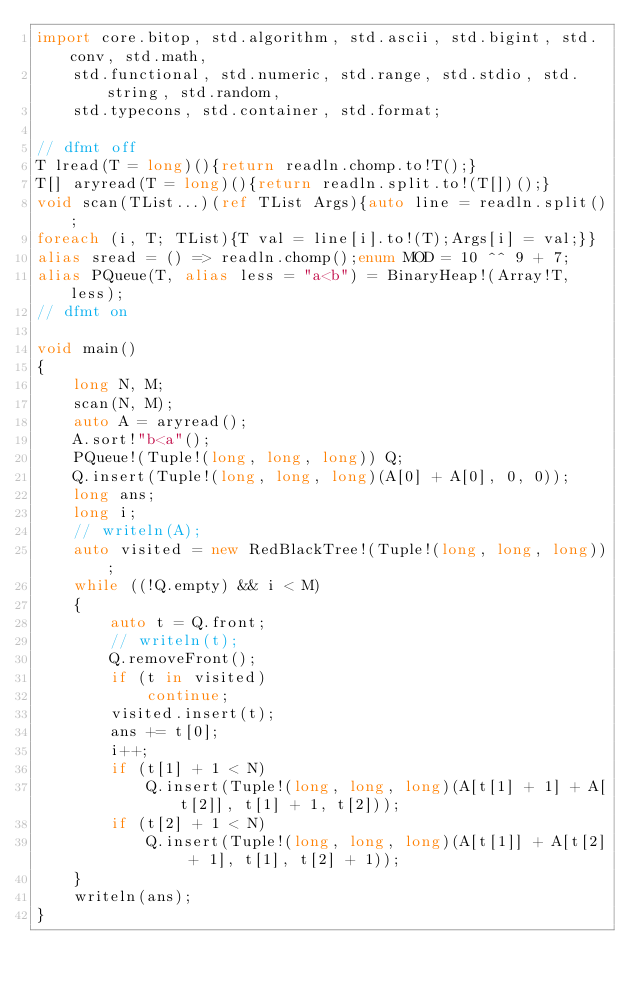Convert code to text. <code><loc_0><loc_0><loc_500><loc_500><_D_>import core.bitop, std.algorithm, std.ascii, std.bigint, std.conv, std.math,
    std.functional, std.numeric, std.range, std.stdio, std.string, std.random,
    std.typecons, std.container, std.format;

// dfmt off
T lread(T = long)(){return readln.chomp.to!T();}
T[] aryread(T = long)(){return readln.split.to!(T[])();}
void scan(TList...)(ref TList Args){auto line = readln.split();
foreach (i, T; TList){T val = line[i].to!(T);Args[i] = val;}}
alias sread = () => readln.chomp();enum MOD = 10 ^^ 9 + 7;
alias PQueue(T, alias less = "a<b") = BinaryHeap!(Array!T, less);
// dfmt on

void main()
{
    long N, M;
    scan(N, M);
    auto A = aryread();
    A.sort!"b<a"();
    PQueue!(Tuple!(long, long, long)) Q;
    Q.insert(Tuple!(long, long, long)(A[0] + A[0], 0, 0));
    long ans;
    long i;
    // writeln(A);
    auto visited = new RedBlackTree!(Tuple!(long, long, long));
    while ((!Q.empty) && i < M)
    {
        auto t = Q.front;
        // writeln(t);
        Q.removeFront();
        if (t in visited)
            continue;
        visited.insert(t);
        ans += t[0];
        i++;
        if (t[1] + 1 < N)
            Q.insert(Tuple!(long, long, long)(A[t[1] + 1] + A[t[2]], t[1] + 1, t[2]));
        if (t[2] + 1 < N)
            Q.insert(Tuple!(long, long, long)(A[t[1]] + A[t[2] + 1], t[1], t[2] + 1));
    }
    writeln(ans);
}
</code> 